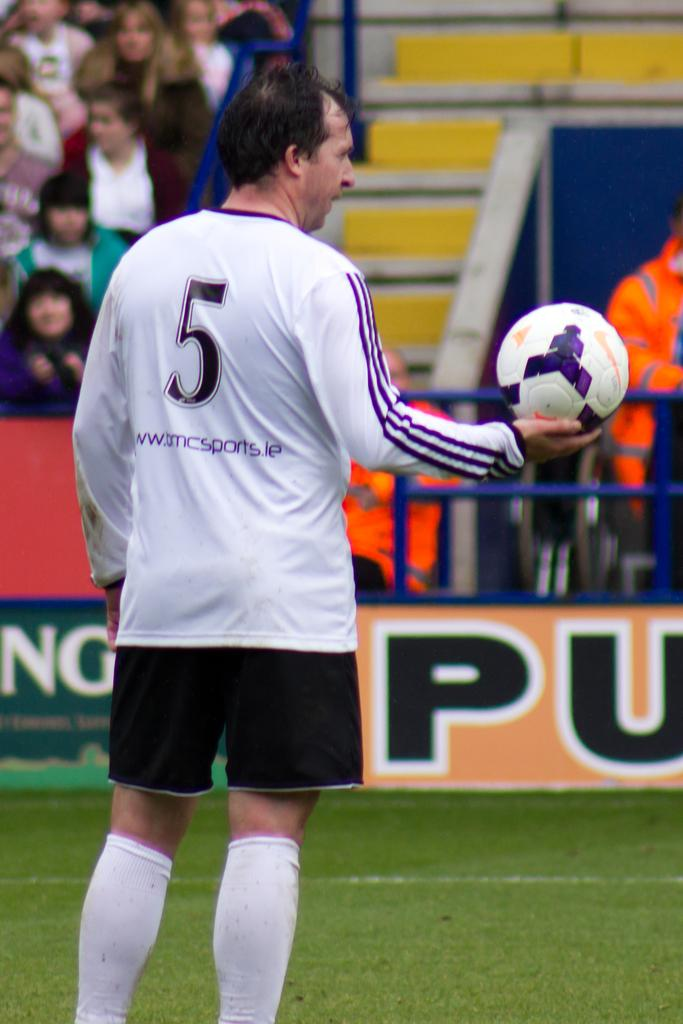<image>
Describe the image concisely. A soccer player holding the ball and his jersey number is 5. 